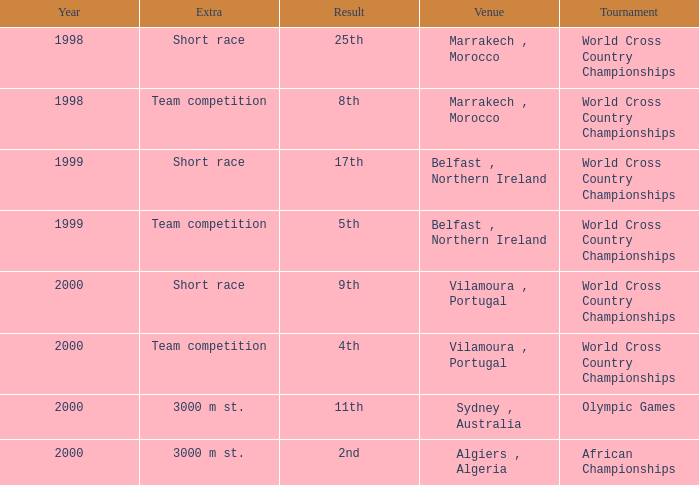Tell me the extra for tournament of olympic games 3000 m st. Could you parse the entire table? {'header': ['Year', 'Extra', 'Result', 'Venue', 'Tournament'], 'rows': [['1998', 'Short race', '25th', 'Marrakech , Morocco', 'World Cross Country Championships'], ['1998', 'Team competition', '8th', 'Marrakech , Morocco', 'World Cross Country Championships'], ['1999', 'Short race', '17th', 'Belfast , Northern Ireland', 'World Cross Country Championships'], ['1999', 'Team competition', '5th', 'Belfast , Northern Ireland', 'World Cross Country Championships'], ['2000', 'Short race', '9th', 'Vilamoura , Portugal', 'World Cross Country Championships'], ['2000', 'Team competition', '4th', 'Vilamoura , Portugal', 'World Cross Country Championships'], ['2000', '3000 m st.', '11th', 'Sydney , Australia', 'Olympic Games'], ['2000', '3000 m st.', '2nd', 'Algiers , Algeria', 'African Championships']]} 